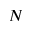Convert formula to latex. <formula><loc_0><loc_0><loc_500><loc_500>N</formula> 